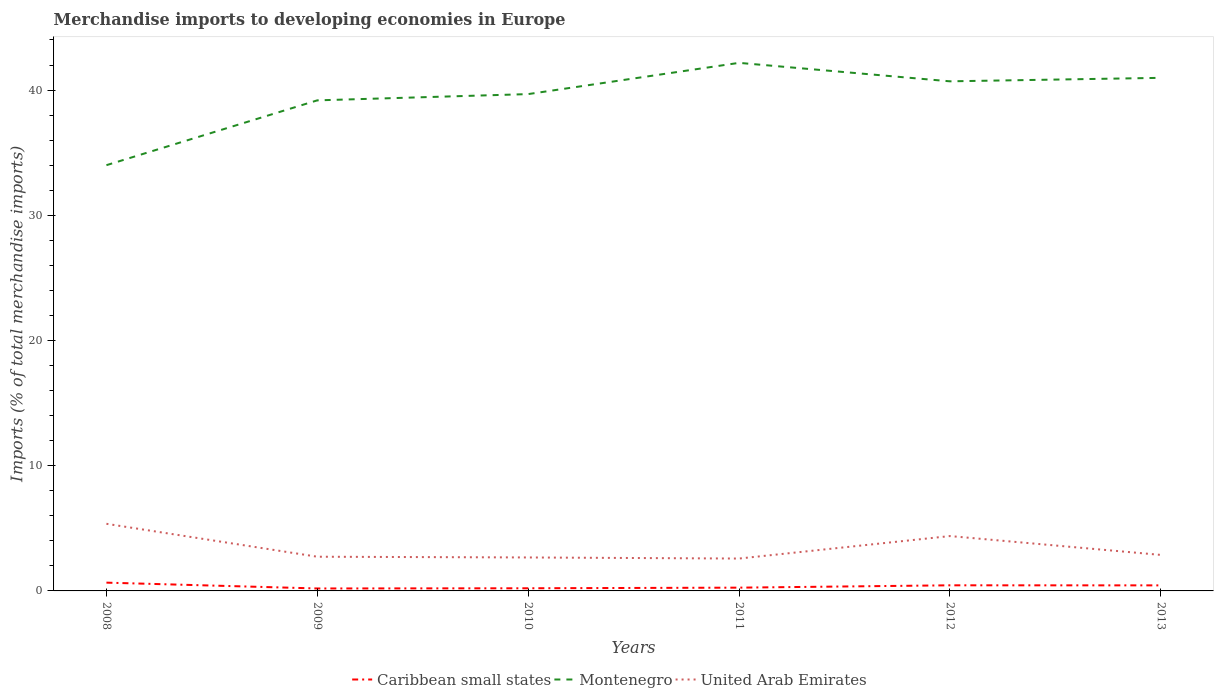How many different coloured lines are there?
Your answer should be very brief. 3. Is the number of lines equal to the number of legend labels?
Keep it short and to the point. Yes. Across all years, what is the maximum percentage total merchandise imports in Caribbean small states?
Provide a short and direct response. 0.2. In which year was the percentage total merchandise imports in Caribbean small states maximum?
Offer a terse response. 2009. What is the total percentage total merchandise imports in Montenegro in the graph?
Your response must be concise. -6.97. What is the difference between the highest and the second highest percentage total merchandise imports in United Arab Emirates?
Keep it short and to the point. 2.78. What is the difference between the highest and the lowest percentage total merchandise imports in Caribbean small states?
Your answer should be very brief. 3. Are the values on the major ticks of Y-axis written in scientific E-notation?
Ensure brevity in your answer.  No. Does the graph contain any zero values?
Your response must be concise. No. Does the graph contain grids?
Offer a terse response. No. What is the title of the graph?
Your answer should be very brief. Merchandise imports to developing economies in Europe. Does "Gabon" appear as one of the legend labels in the graph?
Give a very brief answer. No. What is the label or title of the Y-axis?
Give a very brief answer. Imports (% of total merchandise imports). What is the Imports (% of total merchandise imports) of Caribbean small states in 2008?
Your response must be concise. 0.66. What is the Imports (% of total merchandise imports) in Montenegro in 2008?
Provide a succinct answer. 34. What is the Imports (% of total merchandise imports) in United Arab Emirates in 2008?
Keep it short and to the point. 5.36. What is the Imports (% of total merchandise imports) in Caribbean small states in 2009?
Give a very brief answer. 0.2. What is the Imports (% of total merchandise imports) of Montenegro in 2009?
Your response must be concise. 39.18. What is the Imports (% of total merchandise imports) of United Arab Emirates in 2009?
Give a very brief answer. 2.73. What is the Imports (% of total merchandise imports) in Caribbean small states in 2010?
Make the answer very short. 0.21. What is the Imports (% of total merchandise imports) in Montenegro in 2010?
Provide a short and direct response. 39.68. What is the Imports (% of total merchandise imports) in United Arab Emirates in 2010?
Your answer should be very brief. 2.67. What is the Imports (% of total merchandise imports) in Caribbean small states in 2011?
Offer a terse response. 0.26. What is the Imports (% of total merchandise imports) of Montenegro in 2011?
Offer a very short reply. 42.17. What is the Imports (% of total merchandise imports) of United Arab Emirates in 2011?
Provide a succinct answer. 2.59. What is the Imports (% of total merchandise imports) in Caribbean small states in 2012?
Offer a terse response. 0.45. What is the Imports (% of total merchandise imports) in Montenegro in 2012?
Your answer should be very brief. 40.7. What is the Imports (% of total merchandise imports) of United Arab Emirates in 2012?
Your answer should be compact. 4.38. What is the Imports (% of total merchandise imports) of Caribbean small states in 2013?
Your answer should be compact. 0.44. What is the Imports (% of total merchandise imports) of Montenegro in 2013?
Provide a succinct answer. 40.98. What is the Imports (% of total merchandise imports) in United Arab Emirates in 2013?
Ensure brevity in your answer.  2.88. Across all years, what is the maximum Imports (% of total merchandise imports) in Caribbean small states?
Ensure brevity in your answer.  0.66. Across all years, what is the maximum Imports (% of total merchandise imports) of Montenegro?
Your answer should be compact. 42.17. Across all years, what is the maximum Imports (% of total merchandise imports) in United Arab Emirates?
Offer a terse response. 5.36. Across all years, what is the minimum Imports (% of total merchandise imports) of Caribbean small states?
Give a very brief answer. 0.2. Across all years, what is the minimum Imports (% of total merchandise imports) in Montenegro?
Make the answer very short. 34. Across all years, what is the minimum Imports (% of total merchandise imports) of United Arab Emirates?
Offer a very short reply. 2.59. What is the total Imports (% of total merchandise imports) of Caribbean small states in the graph?
Keep it short and to the point. 2.22. What is the total Imports (% of total merchandise imports) of Montenegro in the graph?
Keep it short and to the point. 236.71. What is the total Imports (% of total merchandise imports) in United Arab Emirates in the graph?
Give a very brief answer. 20.61. What is the difference between the Imports (% of total merchandise imports) of Caribbean small states in 2008 and that in 2009?
Give a very brief answer. 0.47. What is the difference between the Imports (% of total merchandise imports) in Montenegro in 2008 and that in 2009?
Give a very brief answer. -5.18. What is the difference between the Imports (% of total merchandise imports) of United Arab Emirates in 2008 and that in 2009?
Your response must be concise. 2.63. What is the difference between the Imports (% of total merchandise imports) in Caribbean small states in 2008 and that in 2010?
Your answer should be very brief. 0.45. What is the difference between the Imports (% of total merchandise imports) in Montenegro in 2008 and that in 2010?
Offer a terse response. -5.68. What is the difference between the Imports (% of total merchandise imports) in United Arab Emirates in 2008 and that in 2010?
Your response must be concise. 2.69. What is the difference between the Imports (% of total merchandise imports) of Caribbean small states in 2008 and that in 2011?
Your answer should be compact. 0.4. What is the difference between the Imports (% of total merchandise imports) of Montenegro in 2008 and that in 2011?
Provide a short and direct response. -8.17. What is the difference between the Imports (% of total merchandise imports) in United Arab Emirates in 2008 and that in 2011?
Give a very brief answer. 2.77. What is the difference between the Imports (% of total merchandise imports) in Caribbean small states in 2008 and that in 2012?
Offer a very short reply. 0.21. What is the difference between the Imports (% of total merchandise imports) of Montenegro in 2008 and that in 2012?
Make the answer very short. -6.7. What is the difference between the Imports (% of total merchandise imports) in Caribbean small states in 2008 and that in 2013?
Offer a very short reply. 0.22. What is the difference between the Imports (% of total merchandise imports) of Montenegro in 2008 and that in 2013?
Ensure brevity in your answer.  -6.97. What is the difference between the Imports (% of total merchandise imports) in United Arab Emirates in 2008 and that in 2013?
Offer a very short reply. 2.48. What is the difference between the Imports (% of total merchandise imports) of Caribbean small states in 2009 and that in 2010?
Your response must be concise. -0.02. What is the difference between the Imports (% of total merchandise imports) in Montenegro in 2009 and that in 2010?
Make the answer very short. -0.5. What is the difference between the Imports (% of total merchandise imports) in United Arab Emirates in 2009 and that in 2010?
Your answer should be very brief. 0.06. What is the difference between the Imports (% of total merchandise imports) in Caribbean small states in 2009 and that in 2011?
Provide a short and direct response. -0.07. What is the difference between the Imports (% of total merchandise imports) of Montenegro in 2009 and that in 2011?
Keep it short and to the point. -2.99. What is the difference between the Imports (% of total merchandise imports) in United Arab Emirates in 2009 and that in 2011?
Give a very brief answer. 0.15. What is the difference between the Imports (% of total merchandise imports) of Caribbean small states in 2009 and that in 2012?
Your answer should be compact. -0.25. What is the difference between the Imports (% of total merchandise imports) in Montenegro in 2009 and that in 2012?
Provide a succinct answer. -1.52. What is the difference between the Imports (% of total merchandise imports) in United Arab Emirates in 2009 and that in 2012?
Make the answer very short. -1.65. What is the difference between the Imports (% of total merchandise imports) in Caribbean small states in 2009 and that in 2013?
Offer a terse response. -0.25. What is the difference between the Imports (% of total merchandise imports) of Montenegro in 2009 and that in 2013?
Provide a short and direct response. -1.8. What is the difference between the Imports (% of total merchandise imports) of United Arab Emirates in 2009 and that in 2013?
Ensure brevity in your answer.  -0.14. What is the difference between the Imports (% of total merchandise imports) in Caribbean small states in 2010 and that in 2011?
Your answer should be very brief. -0.05. What is the difference between the Imports (% of total merchandise imports) in Montenegro in 2010 and that in 2011?
Your response must be concise. -2.49. What is the difference between the Imports (% of total merchandise imports) of United Arab Emirates in 2010 and that in 2011?
Your answer should be compact. 0.09. What is the difference between the Imports (% of total merchandise imports) of Caribbean small states in 2010 and that in 2012?
Provide a succinct answer. -0.24. What is the difference between the Imports (% of total merchandise imports) of Montenegro in 2010 and that in 2012?
Give a very brief answer. -1.02. What is the difference between the Imports (% of total merchandise imports) in United Arab Emirates in 2010 and that in 2012?
Offer a very short reply. -1.71. What is the difference between the Imports (% of total merchandise imports) in Caribbean small states in 2010 and that in 2013?
Provide a short and direct response. -0.23. What is the difference between the Imports (% of total merchandise imports) in Montenegro in 2010 and that in 2013?
Your answer should be compact. -1.3. What is the difference between the Imports (% of total merchandise imports) in United Arab Emirates in 2010 and that in 2013?
Ensure brevity in your answer.  -0.2. What is the difference between the Imports (% of total merchandise imports) of Caribbean small states in 2011 and that in 2012?
Your answer should be very brief. -0.19. What is the difference between the Imports (% of total merchandise imports) of Montenegro in 2011 and that in 2012?
Your response must be concise. 1.47. What is the difference between the Imports (% of total merchandise imports) of United Arab Emirates in 2011 and that in 2012?
Provide a succinct answer. -1.8. What is the difference between the Imports (% of total merchandise imports) in Caribbean small states in 2011 and that in 2013?
Your answer should be compact. -0.18. What is the difference between the Imports (% of total merchandise imports) in Montenegro in 2011 and that in 2013?
Offer a very short reply. 1.2. What is the difference between the Imports (% of total merchandise imports) of United Arab Emirates in 2011 and that in 2013?
Provide a short and direct response. -0.29. What is the difference between the Imports (% of total merchandise imports) of Caribbean small states in 2012 and that in 2013?
Make the answer very short. 0.01. What is the difference between the Imports (% of total merchandise imports) in Montenegro in 2012 and that in 2013?
Provide a succinct answer. -0.28. What is the difference between the Imports (% of total merchandise imports) of United Arab Emirates in 2012 and that in 2013?
Ensure brevity in your answer.  1.51. What is the difference between the Imports (% of total merchandise imports) of Caribbean small states in 2008 and the Imports (% of total merchandise imports) of Montenegro in 2009?
Keep it short and to the point. -38.52. What is the difference between the Imports (% of total merchandise imports) in Caribbean small states in 2008 and the Imports (% of total merchandise imports) in United Arab Emirates in 2009?
Keep it short and to the point. -2.07. What is the difference between the Imports (% of total merchandise imports) of Montenegro in 2008 and the Imports (% of total merchandise imports) of United Arab Emirates in 2009?
Your answer should be compact. 31.27. What is the difference between the Imports (% of total merchandise imports) of Caribbean small states in 2008 and the Imports (% of total merchandise imports) of Montenegro in 2010?
Provide a succinct answer. -39.02. What is the difference between the Imports (% of total merchandise imports) of Caribbean small states in 2008 and the Imports (% of total merchandise imports) of United Arab Emirates in 2010?
Your response must be concise. -2.01. What is the difference between the Imports (% of total merchandise imports) of Montenegro in 2008 and the Imports (% of total merchandise imports) of United Arab Emirates in 2010?
Offer a very short reply. 31.33. What is the difference between the Imports (% of total merchandise imports) in Caribbean small states in 2008 and the Imports (% of total merchandise imports) in Montenegro in 2011?
Give a very brief answer. -41.51. What is the difference between the Imports (% of total merchandise imports) of Caribbean small states in 2008 and the Imports (% of total merchandise imports) of United Arab Emirates in 2011?
Make the answer very short. -1.92. What is the difference between the Imports (% of total merchandise imports) in Montenegro in 2008 and the Imports (% of total merchandise imports) in United Arab Emirates in 2011?
Offer a very short reply. 31.42. What is the difference between the Imports (% of total merchandise imports) of Caribbean small states in 2008 and the Imports (% of total merchandise imports) of Montenegro in 2012?
Ensure brevity in your answer.  -40.04. What is the difference between the Imports (% of total merchandise imports) of Caribbean small states in 2008 and the Imports (% of total merchandise imports) of United Arab Emirates in 2012?
Your answer should be very brief. -3.72. What is the difference between the Imports (% of total merchandise imports) of Montenegro in 2008 and the Imports (% of total merchandise imports) of United Arab Emirates in 2012?
Ensure brevity in your answer.  29.62. What is the difference between the Imports (% of total merchandise imports) of Caribbean small states in 2008 and the Imports (% of total merchandise imports) of Montenegro in 2013?
Your response must be concise. -40.32. What is the difference between the Imports (% of total merchandise imports) in Caribbean small states in 2008 and the Imports (% of total merchandise imports) in United Arab Emirates in 2013?
Your response must be concise. -2.21. What is the difference between the Imports (% of total merchandise imports) of Montenegro in 2008 and the Imports (% of total merchandise imports) of United Arab Emirates in 2013?
Your response must be concise. 31.13. What is the difference between the Imports (% of total merchandise imports) of Caribbean small states in 2009 and the Imports (% of total merchandise imports) of Montenegro in 2010?
Offer a very short reply. -39.48. What is the difference between the Imports (% of total merchandise imports) in Caribbean small states in 2009 and the Imports (% of total merchandise imports) in United Arab Emirates in 2010?
Your response must be concise. -2.48. What is the difference between the Imports (% of total merchandise imports) in Montenegro in 2009 and the Imports (% of total merchandise imports) in United Arab Emirates in 2010?
Your response must be concise. 36.51. What is the difference between the Imports (% of total merchandise imports) in Caribbean small states in 2009 and the Imports (% of total merchandise imports) in Montenegro in 2011?
Your answer should be compact. -41.98. What is the difference between the Imports (% of total merchandise imports) of Caribbean small states in 2009 and the Imports (% of total merchandise imports) of United Arab Emirates in 2011?
Provide a short and direct response. -2.39. What is the difference between the Imports (% of total merchandise imports) of Montenegro in 2009 and the Imports (% of total merchandise imports) of United Arab Emirates in 2011?
Make the answer very short. 36.59. What is the difference between the Imports (% of total merchandise imports) of Caribbean small states in 2009 and the Imports (% of total merchandise imports) of Montenegro in 2012?
Provide a succinct answer. -40.5. What is the difference between the Imports (% of total merchandise imports) of Caribbean small states in 2009 and the Imports (% of total merchandise imports) of United Arab Emirates in 2012?
Keep it short and to the point. -4.19. What is the difference between the Imports (% of total merchandise imports) of Montenegro in 2009 and the Imports (% of total merchandise imports) of United Arab Emirates in 2012?
Offer a very short reply. 34.8. What is the difference between the Imports (% of total merchandise imports) of Caribbean small states in 2009 and the Imports (% of total merchandise imports) of Montenegro in 2013?
Provide a short and direct response. -40.78. What is the difference between the Imports (% of total merchandise imports) in Caribbean small states in 2009 and the Imports (% of total merchandise imports) in United Arab Emirates in 2013?
Make the answer very short. -2.68. What is the difference between the Imports (% of total merchandise imports) in Montenegro in 2009 and the Imports (% of total merchandise imports) in United Arab Emirates in 2013?
Your answer should be very brief. 36.3. What is the difference between the Imports (% of total merchandise imports) of Caribbean small states in 2010 and the Imports (% of total merchandise imports) of Montenegro in 2011?
Your response must be concise. -41.96. What is the difference between the Imports (% of total merchandise imports) in Caribbean small states in 2010 and the Imports (% of total merchandise imports) in United Arab Emirates in 2011?
Keep it short and to the point. -2.37. What is the difference between the Imports (% of total merchandise imports) in Montenegro in 2010 and the Imports (% of total merchandise imports) in United Arab Emirates in 2011?
Make the answer very short. 37.09. What is the difference between the Imports (% of total merchandise imports) of Caribbean small states in 2010 and the Imports (% of total merchandise imports) of Montenegro in 2012?
Offer a very short reply. -40.49. What is the difference between the Imports (% of total merchandise imports) of Caribbean small states in 2010 and the Imports (% of total merchandise imports) of United Arab Emirates in 2012?
Offer a very short reply. -4.17. What is the difference between the Imports (% of total merchandise imports) in Montenegro in 2010 and the Imports (% of total merchandise imports) in United Arab Emirates in 2012?
Provide a short and direct response. 35.3. What is the difference between the Imports (% of total merchandise imports) of Caribbean small states in 2010 and the Imports (% of total merchandise imports) of Montenegro in 2013?
Provide a short and direct response. -40.76. What is the difference between the Imports (% of total merchandise imports) of Caribbean small states in 2010 and the Imports (% of total merchandise imports) of United Arab Emirates in 2013?
Provide a succinct answer. -2.66. What is the difference between the Imports (% of total merchandise imports) in Montenegro in 2010 and the Imports (% of total merchandise imports) in United Arab Emirates in 2013?
Ensure brevity in your answer.  36.8. What is the difference between the Imports (% of total merchandise imports) of Caribbean small states in 2011 and the Imports (% of total merchandise imports) of Montenegro in 2012?
Make the answer very short. -40.44. What is the difference between the Imports (% of total merchandise imports) of Caribbean small states in 2011 and the Imports (% of total merchandise imports) of United Arab Emirates in 2012?
Make the answer very short. -4.12. What is the difference between the Imports (% of total merchandise imports) in Montenegro in 2011 and the Imports (% of total merchandise imports) in United Arab Emirates in 2012?
Your answer should be very brief. 37.79. What is the difference between the Imports (% of total merchandise imports) of Caribbean small states in 2011 and the Imports (% of total merchandise imports) of Montenegro in 2013?
Offer a very short reply. -40.72. What is the difference between the Imports (% of total merchandise imports) in Caribbean small states in 2011 and the Imports (% of total merchandise imports) in United Arab Emirates in 2013?
Make the answer very short. -2.61. What is the difference between the Imports (% of total merchandise imports) in Montenegro in 2011 and the Imports (% of total merchandise imports) in United Arab Emirates in 2013?
Your answer should be very brief. 39.3. What is the difference between the Imports (% of total merchandise imports) of Caribbean small states in 2012 and the Imports (% of total merchandise imports) of Montenegro in 2013?
Offer a terse response. -40.53. What is the difference between the Imports (% of total merchandise imports) in Caribbean small states in 2012 and the Imports (% of total merchandise imports) in United Arab Emirates in 2013?
Your response must be concise. -2.43. What is the difference between the Imports (% of total merchandise imports) in Montenegro in 2012 and the Imports (% of total merchandise imports) in United Arab Emirates in 2013?
Ensure brevity in your answer.  37.82. What is the average Imports (% of total merchandise imports) of Caribbean small states per year?
Offer a terse response. 0.37. What is the average Imports (% of total merchandise imports) of Montenegro per year?
Offer a terse response. 39.45. What is the average Imports (% of total merchandise imports) of United Arab Emirates per year?
Offer a very short reply. 3.43. In the year 2008, what is the difference between the Imports (% of total merchandise imports) of Caribbean small states and Imports (% of total merchandise imports) of Montenegro?
Your response must be concise. -33.34. In the year 2008, what is the difference between the Imports (% of total merchandise imports) of Caribbean small states and Imports (% of total merchandise imports) of United Arab Emirates?
Ensure brevity in your answer.  -4.7. In the year 2008, what is the difference between the Imports (% of total merchandise imports) in Montenegro and Imports (% of total merchandise imports) in United Arab Emirates?
Your answer should be compact. 28.64. In the year 2009, what is the difference between the Imports (% of total merchandise imports) of Caribbean small states and Imports (% of total merchandise imports) of Montenegro?
Your answer should be very brief. -38.98. In the year 2009, what is the difference between the Imports (% of total merchandise imports) in Caribbean small states and Imports (% of total merchandise imports) in United Arab Emirates?
Ensure brevity in your answer.  -2.54. In the year 2009, what is the difference between the Imports (% of total merchandise imports) of Montenegro and Imports (% of total merchandise imports) of United Arab Emirates?
Ensure brevity in your answer.  36.45. In the year 2010, what is the difference between the Imports (% of total merchandise imports) in Caribbean small states and Imports (% of total merchandise imports) in Montenegro?
Provide a succinct answer. -39.47. In the year 2010, what is the difference between the Imports (% of total merchandise imports) in Caribbean small states and Imports (% of total merchandise imports) in United Arab Emirates?
Give a very brief answer. -2.46. In the year 2010, what is the difference between the Imports (% of total merchandise imports) of Montenegro and Imports (% of total merchandise imports) of United Arab Emirates?
Give a very brief answer. 37.01. In the year 2011, what is the difference between the Imports (% of total merchandise imports) of Caribbean small states and Imports (% of total merchandise imports) of Montenegro?
Provide a short and direct response. -41.91. In the year 2011, what is the difference between the Imports (% of total merchandise imports) of Caribbean small states and Imports (% of total merchandise imports) of United Arab Emirates?
Provide a succinct answer. -2.32. In the year 2011, what is the difference between the Imports (% of total merchandise imports) of Montenegro and Imports (% of total merchandise imports) of United Arab Emirates?
Provide a succinct answer. 39.59. In the year 2012, what is the difference between the Imports (% of total merchandise imports) of Caribbean small states and Imports (% of total merchandise imports) of Montenegro?
Provide a short and direct response. -40.25. In the year 2012, what is the difference between the Imports (% of total merchandise imports) of Caribbean small states and Imports (% of total merchandise imports) of United Arab Emirates?
Your answer should be very brief. -3.93. In the year 2012, what is the difference between the Imports (% of total merchandise imports) of Montenegro and Imports (% of total merchandise imports) of United Arab Emirates?
Your response must be concise. 36.32. In the year 2013, what is the difference between the Imports (% of total merchandise imports) of Caribbean small states and Imports (% of total merchandise imports) of Montenegro?
Make the answer very short. -40.53. In the year 2013, what is the difference between the Imports (% of total merchandise imports) in Caribbean small states and Imports (% of total merchandise imports) in United Arab Emirates?
Make the answer very short. -2.43. In the year 2013, what is the difference between the Imports (% of total merchandise imports) of Montenegro and Imports (% of total merchandise imports) of United Arab Emirates?
Give a very brief answer. 38.1. What is the ratio of the Imports (% of total merchandise imports) in Caribbean small states in 2008 to that in 2009?
Give a very brief answer. 3.38. What is the ratio of the Imports (% of total merchandise imports) in Montenegro in 2008 to that in 2009?
Your response must be concise. 0.87. What is the ratio of the Imports (% of total merchandise imports) in United Arab Emirates in 2008 to that in 2009?
Offer a very short reply. 1.96. What is the ratio of the Imports (% of total merchandise imports) in Caribbean small states in 2008 to that in 2010?
Your answer should be compact. 3.12. What is the ratio of the Imports (% of total merchandise imports) in Montenegro in 2008 to that in 2010?
Give a very brief answer. 0.86. What is the ratio of the Imports (% of total merchandise imports) of United Arab Emirates in 2008 to that in 2010?
Offer a very short reply. 2.01. What is the ratio of the Imports (% of total merchandise imports) in Caribbean small states in 2008 to that in 2011?
Your answer should be very brief. 2.53. What is the ratio of the Imports (% of total merchandise imports) in Montenegro in 2008 to that in 2011?
Your response must be concise. 0.81. What is the ratio of the Imports (% of total merchandise imports) in United Arab Emirates in 2008 to that in 2011?
Offer a terse response. 2.07. What is the ratio of the Imports (% of total merchandise imports) in Caribbean small states in 2008 to that in 2012?
Offer a very short reply. 1.47. What is the ratio of the Imports (% of total merchandise imports) of Montenegro in 2008 to that in 2012?
Offer a terse response. 0.84. What is the ratio of the Imports (% of total merchandise imports) in United Arab Emirates in 2008 to that in 2012?
Keep it short and to the point. 1.22. What is the ratio of the Imports (% of total merchandise imports) in Caribbean small states in 2008 to that in 2013?
Provide a short and direct response. 1.49. What is the ratio of the Imports (% of total merchandise imports) of Montenegro in 2008 to that in 2013?
Offer a terse response. 0.83. What is the ratio of the Imports (% of total merchandise imports) in United Arab Emirates in 2008 to that in 2013?
Provide a succinct answer. 1.86. What is the ratio of the Imports (% of total merchandise imports) in Caribbean small states in 2009 to that in 2010?
Give a very brief answer. 0.92. What is the ratio of the Imports (% of total merchandise imports) in Montenegro in 2009 to that in 2010?
Give a very brief answer. 0.99. What is the ratio of the Imports (% of total merchandise imports) of Caribbean small states in 2009 to that in 2011?
Make the answer very short. 0.75. What is the ratio of the Imports (% of total merchandise imports) in Montenegro in 2009 to that in 2011?
Your response must be concise. 0.93. What is the ratio of the Imports (% of total merchandise imports) in United Arab Emirates in 2009 to that in 2011?
Provide a succinct answer. 1.06. What is the ratio of the Imports (% of total merchandise imports) of Caribbean small states in 2009 to that in 2012?
Your answer should be compact. 0.44. What is the ratio of the Imports (% of total merchandise imports) of Montenegro in 2009 to that in 2012?
Offer a very short reply. 0.96. What is the ratio of the Imports (% of total merchandise imports) of United Arab Emirates in 2009 to that in 2012?
Offer a terse response. 0.62. What is the ratio of the Imports (% of total merchandise imports) of Caribbean small states in 2009 to that in 2013?
Keep it short and to the point. 0.44. What is the ratio of the Imports (% of total merchandise imports) of Montenegro in 2009 to that in 2013?
Ensure brevity in your answer.  0.96. What is the ratio of the Imports (% of total merchandise imports) of United Arab Emirates in 2009 to that in 2013?
Give a very brief answer. 0.95. What is the ratio of the Imports (% of total merchandise imports) in Caribbean small states in 2010 to that in 2011?
Give a very brief answer. 0.81. What is the ratio of the Imports (% of total merchandise imports) in Montenegro in 2010 to that in 2011?
Your response must be concise. 0.94. What is the ratio of the Imports (% of total merchandise imports) in United Arab Emirates in 2010 to that in 2011?
Offer a terse response. 1.03. What is the ratio of the Imports (% of total merchandise imports) in Caribbean small states in 2010 to that in 2012?
Your answer should be very brief. 0.47. What is the ratio of the Imports (% of total merchandise imports) of Montenegro in 2010 to that in 2012?
Ensure brevity in your answer.  0.97. What is the ratio of the Imports (% of total merchandise imports) of United Arab Emirates in 2010 to that in 2012?
Ensure brevity in your answer.  0.61. What is the ratio of the Imports (% of total merchandise imports) of Caribbean small states in 2010 to that in 2013?
Your response must be concise. 0.48. What is the ratio of the Imports (% of total merchandise imports) in Montenegro in 2010 to that in 2013?
Offer a terse response. 0.97. What is the ratio of the Imports (% of total merchandise imports) in United Arab Emirates in 2010 to that in 2013?
Keep it short and to the point. 0.93. What is the ratio of the Imports (% of total merchandise imports) of Caribbean small states in 2011 to that in 2012?
Offer a very short reply. 0.58. What is the ratio of the Imports (% of total merchandise imports) in Montenegro in 2011 to that in 2012?
Your response must be concise. 1.04. What is the ratio of the Imports (% of total merchandise imports) in United Arab Emirates in 2011 to that in 2012?
Your response must be concise. 0.59. What is the ratio of the Imports (% of total merchandise imports) in Caribbean small states in 2011 to that in 2013?
Ensure brevity in your answer.  0.59. What is the ratio of the Imports (% of total merchandise imports) of Montenegro in 2011 to that in 2013?
Your response must be concise. 1.03. What is the ratio of the Imports (% of total merchandise imports) in United Arab Emirates in 2011 to that in 2013?
Your response must be concise. 0.9. What is the ratio of the Imports (% of total merchandise imports) of Caribbean small states in 2012 to that in 2013?
Provide a succinct answer. 1.01. What is the ratio of the Imports (% of total merchandise imports) in United Arab Emirates in 2012 to that in 2013?
Offer a very short reply. 1.52. What is the difference between the highest and the second highest Imports (% of total merchandise imports) of Caribbean small states?
Make the answer very short. 0.21. What is the difference between the highest and the second highest Imports (% of total merchandise imports) of Montenegro?
Offer a terse response. 1.2. What is the difference between the highest and the lowest Imports (% of total merchandise imports) in Caribbean small states?
Give a very brief answer. 0.47. What is the difference between the highest and the lowest Imports (% of total merchandise imports) in Montenegro?
Your answer should be very brief. 8.17. What is the difference between the highest and the lowest Imports (% of total merchandise imports) in United Arab Emirates?
Your answer should be very brief. 2.77. 